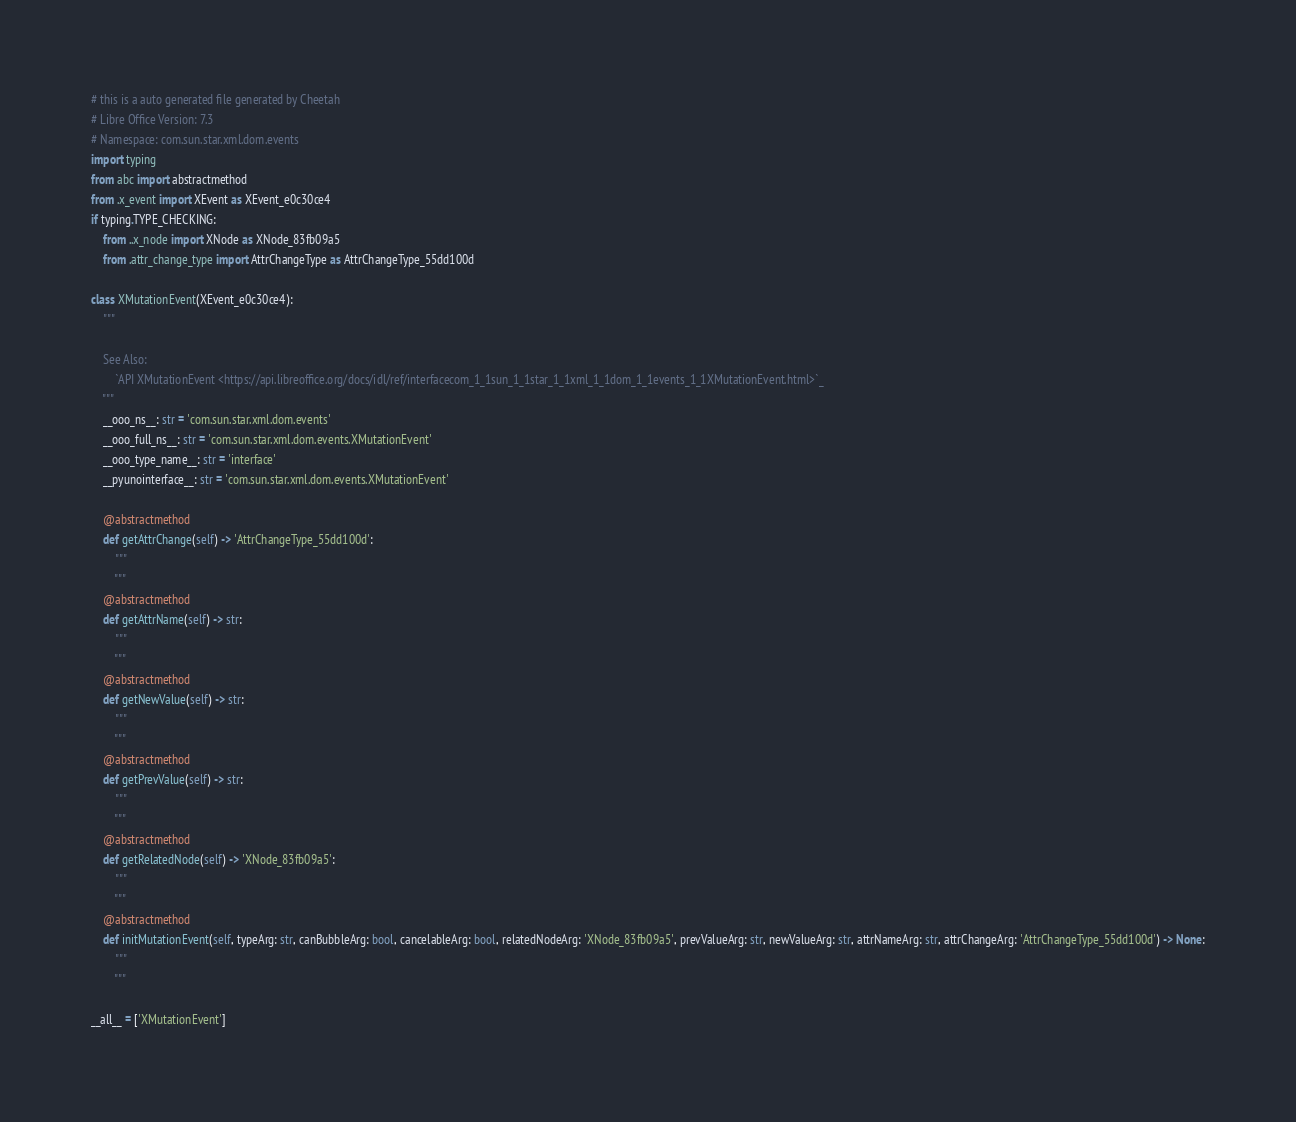<code> <loc_0><loc_0><loc_500><loc_500><_Python_># this is a auto generated file generated by Cheetah
# Libre Office Version: 7.3
# Namespace: com.sun.star.xml.dom.events
import typing
from abc import abstractmethod
from .x_event import XEvent as XEvent_e0c30ce4
if typing.TYPE_CHECKING:
    from ..x_node import XNode as XNode_83fb09a5
    from .attr_change_type import AttrChangeType as AttrChangeType_55dd100d

class XMutationEvent(XEvent_e0c30ce4):
    """

    See Also:
        `API XMutationEvent <https://api.libreoffice.org/docs/idl/ref/interfacecom_1_1sun_1_1star_1_1xml_1_1dom_1_1events_1_1XMutationEvent.html>`_
    """
    __ooo_ns__: str = 'com.sun.star.xml.dom.events'
    __ooo_full_ns__: str = 'com.sun.star.xml.dom.events.XMutationEvent'
    __ooo_type_name__: str = 'interface'
    __pyunointerface__: str = 'com.sun.star.xml.dom.events.XMutationEvent'

    @abstractmethod
    def getAttrChange(self) -> 'AttrChangeType_55dd100d':
        """
        """
    @abstractmethod
    def getAttrName(self) -> str:
        """
        """
    @abstractmethod
    def getNewValue(self) -> str:
        """
        """
    @abstractmethod
    def getPrevValue(self) -> str:
        """
        """
    @abstractmethod
    def getRelatedNode(self) -> 'XNode_83fb09a5':
        """
        """
    @abstractmethod
    def initMutationEvent(self, typeArg: str, canBubbleArg: bool, cancelableArg: bool, relatedNodeArg: 'XNode_83fb09a5', prevValueArg: str, newValueArg: str, attrNameArg: str, attrChangeArg: 'AttrChangeType_55dd100d') -> None:
        """
        """

__all__ = ['XMutationEvent']

</code> 